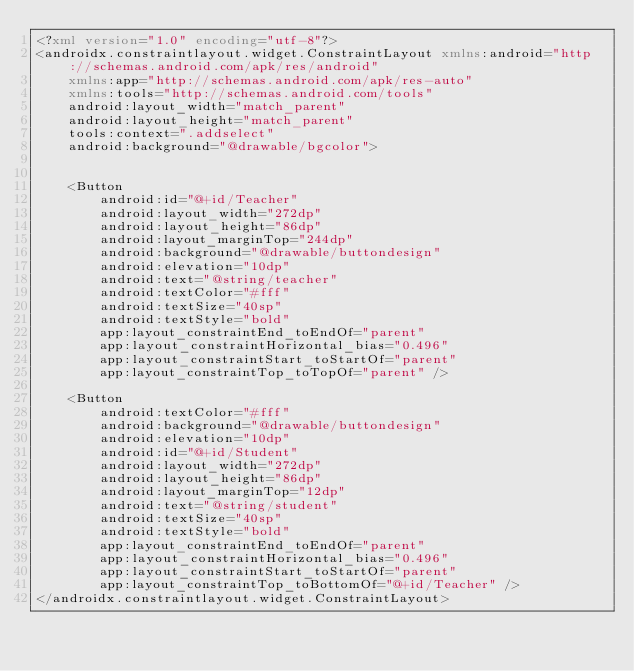<code> <loc_0><loc_0><loc_500><loc_500><_XML_><?xml version="1.0" encoding="utf-8"?>
<androidx.constraintlayout.widget.ConstraintLayout xmlns:android="http://schemas.android.com/apk/res/android"
    xmlns:app="http://schemas.android.com/apk/res-auto"
    xmlns:tools="http://schemas.android.com/tools"
    android:layout_width="match_parent"
    android:layout_height="match_parent"
    tools:context=".addselect"
    android:background="@drawable/bgcolor">


    <Button
        android:id="@+id/Teacher"
        android:layout_width="272dp"
        android:layout_height="86dp"
        android:layout_marginTop="244dp"
        android:background="@drawable/buttondesign"
        android:elevation="10dp"
        android:text="@string/teacher"
        android:textColor="#fff"
        android:textSize="40sp"
        android:textStyle="bold"
        app:layout_constraintEnd_toEndOf="parent"
        app:layout_constraintHorizontal_bias="0.496"
        app:layout_constraintStart_toStartOf="parent"
        app:layout_constraintTop_toTopOf="parent" />

    <Button
        android:textColor="#fff"
        android:background="@drawable/buttondesign"
        android:elevation="10dp"
        android:id="@+id/Student"
        android:layout_width="272dp"
        android:layout_height="86dp"
        android:layout_marginTop="12dp"
        android:text="@string/student"
        android:textSize="40sp"
        android:textStyle="bold"
        app:layout_constraintEnd_toEndOf="parent"
        app:layout_constraintHorizontal_bias="0.496"
        app:layout_constraintStart_toStartOf="parent"
        app:layout_constraintTop_toBottomOf="@+id/Teacher" />
</androidx.constraintlayout.widget.ConstraintLayout></code> 